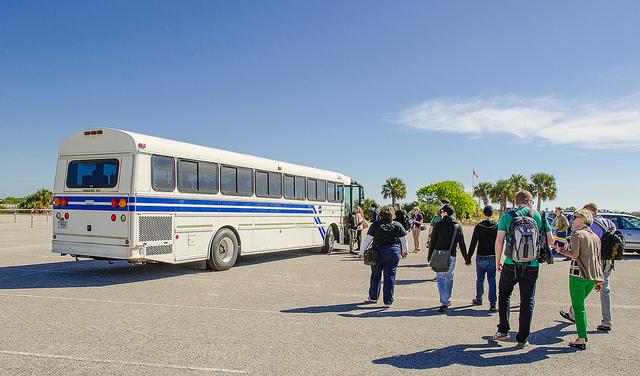What objects are leaning against the bus?
Concise answer only. Nothing. What color is the bus?
Quick response, please. White and blue. How many stories is this bus?
Write a very short answer. 1. Where is the bus parked?
Be succinct. Parking lot. Are these people getting on a bus?
Short answer required. Yes. What are all the people doing?
Concise answer only. Boarding bus. How many people do you see?
Short answer required. 12. What animal is in the lot?
Quick response, please. None. 